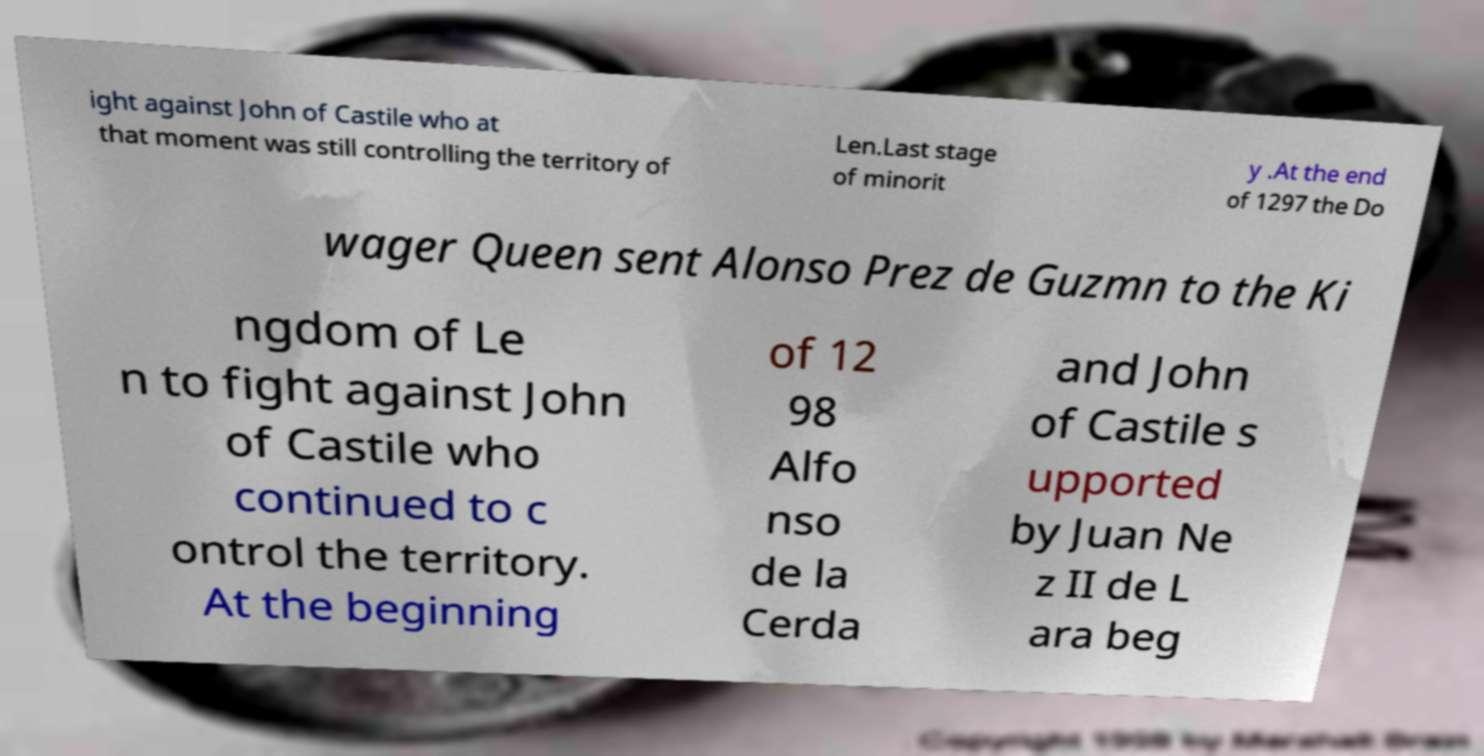Can you read and provide the text displayed in the image?This photo seems to have some interesting text. Can you extract and type it out for me? ight against John of Castile who at that moment was still controlling the territory of Len.Last stage of minorit y .At the end of 1297 the Do wager Queen sent Alonso Prez de Guzmn to the Ki ngdom of Le n to fight against John of Castile who continued to c ontrol the territory. At the beginning of 12 98 Alfo nso de la Cerda and John of Castile s upported by Juan Ne z II de L ara beg 